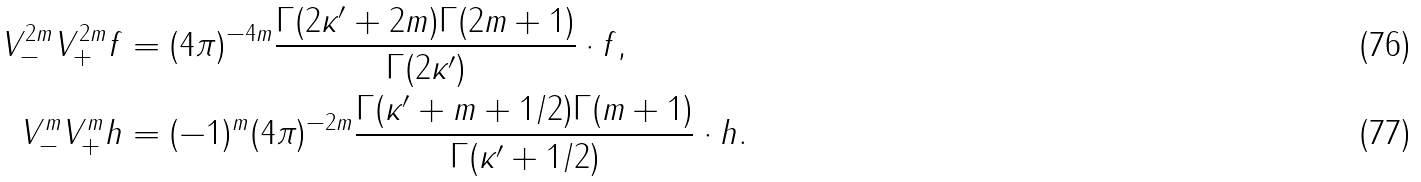Convert formula to latex. <formula><loc_0><loc_0><loc_500><loc_500>V _ { - } ^ { 2 m } V _ { + } ^ { 2 m } { f } & = ( 4 \pi ) ^ { - 4 m } \frac { \Gamma ( 2 \kappa ^ { \prime } + 2 m ) \Gamma ( 2 m + 1 ) } { \Gamma ( 2 \kappa ^ { \prime } ) } \cdot { f } , \\ V _ { - } ^ { m } V _ { + } ^ { m } { h } & = ( - 1 ) ^ { m } ( 4 \pi ) ^ { - 2 m } \frac { \Gamma ( \kappa ^ { \prime } + m + 1 / 2 ) \Gamma ( m + 1 ) } { \Gamma ( \kappa ^ { \prime } + 1 / 2 ) } \cdot { h } .</formula> 